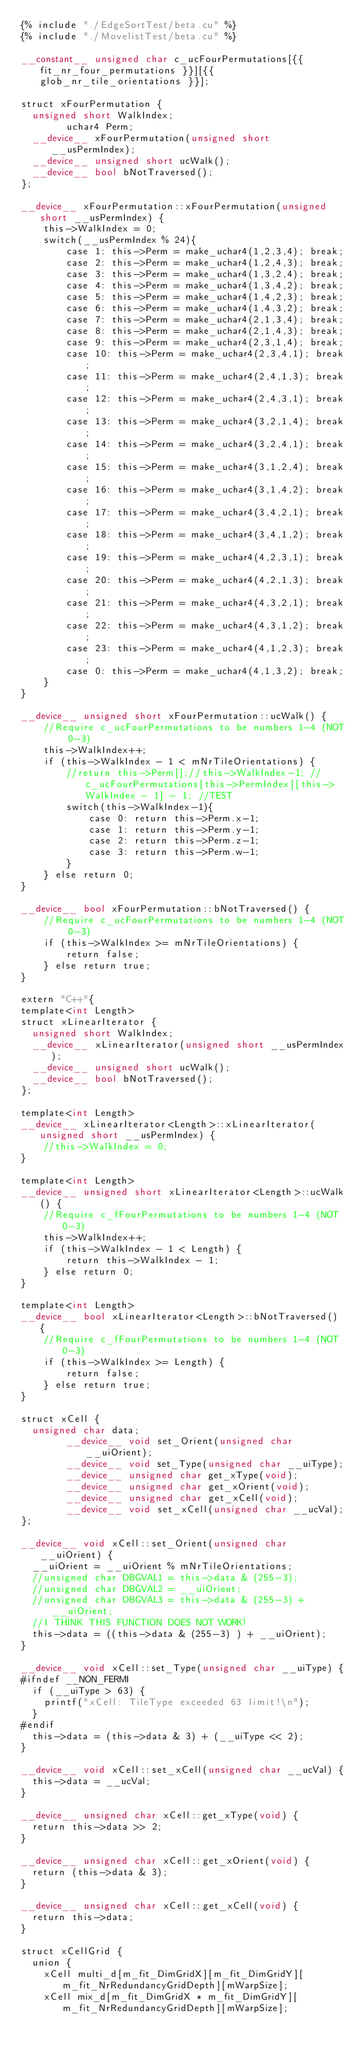Convert code to text. <code><loc_0><loc_0><loc_500><loc_500><_Cuda_>{% include "./EdgeSortTest/beta.cu" %}
{% include "./MovelistTest/beta.cu" %}

__constant__ unsigned char c_ucFourPermutations[{{ fit_nr_four_permutations }}][{{ glob_nr_tile_orientations }}];

struct xFourPermutation {
	unsigned short WalkIndex;
        uchar4 Perm;
	__device__ xFourPermutation(unsigned short __usPermIndex);
	__device__ unsigned short ucWalk();
	__device__ bool bNotTraversed();
};

__device__ xFourPermutation::xFourPermutation(unsigned short __usPermIndex) {
    this->WalkIndex = 0;
    switch(__usPermIndex % 24){
        case 1: this->Perm = make_uchar4(1,2,3,4); break;
        case 2: this->Perm = make_uchar4(1,2,4,3); break;
        case 3: this->Perm = make_uchar4(1,3,2,4); break;
        case 4: this->Perm = make_uchar4(1,3,4,2); break;
        case 5: this->Perm = make_uchar4(1,4,2,3); break;
        case 6: this->Perm = make_uchar4(1,4,3,2); break;
        case 7: this->Perm = make_uchar4(2,1,3,4); break;
        case 8: this->Perm = make_uchar4(2,1,4,3); break;
        case 9: this->Perm = make_uchar4(2,3,1,4); break;
        case 10: this->Perm = make_uchar4(2,3,4,1); break;
        case 11: this->Perm = make_uchar4(2,4,1,3); break;
        case 12: this->Perm = make_uchar4(2,4,3,1); break;
        case 13: this->Perm = make_uchar4(3,2,1,4); break;
        case 14: this->Perm = make_uchar4(3,2,4,1); break;
        case 15: this->Perm = make_uchar4(3,1,2,4); break;
        case 16: this->Perm = make_uchar4(3,1,4,2); break;
        case 17: this->Perm = make_uchar4(3,4,2,1); break;
        case 18: this->Perm = make_uchar4(3,4,1,2); break;
        case 19: this->Perm = make_uchar4(4,2,3,1); break;
        case 20: this->Perm = make_uchar4(4,2,1,3); break;
        case 21: this->Perm = make_uchar4(4,3,2,1); break;
        case 22: this->Perm = make_uchar4(4,3,1,2); break;
        case 23: this->Perm = make_uchar4(4,1,2,3); break;
        case 0: this->Perm = make_uchar4(4,1,3,2); break;
    }
}

__device__ unsigned short xFourPermutation::ucWalk() {
    //Require c_ucFourPermutations to be numbers 1-4 (NOT 0-3)
    this->WalkIndex++;
    if (this->WalkIndex - 1 < mNrTileOrientations) {
        //return this->Perm[];//this->WalkIndex-1; //c_ucFourPermutations[this->PermIndex][this->WalkIndex - 1] - 1; //TEST
        switch(this->WalkIndex-1){
            case 0: return this->Perm.x-1;
            case 1: return this->Perm.y-1;
            case 2: return this->Perm.z-1;
            case 3: return this->Perm.w-1;            
        }
    } else return 0;
}

__device__ bool xFourPermutation::bNotTraversed() {
    //Require c_ucFourPermutations to be numbers 1-4 (NOT 0-3)
    if (this->WalkIndex >= mNrTileOrientations) {
        return false;
    } else return true;
}

extern "C++"{
template<int Length>
struct xLinearIterator {
	unsigned short WalkIndex;
	__device__ xLinearIterator(unsigned short __usPermIndex);
	__device__ unsigned short ucWalk();
	__device__ bool bNotTraversed();
};

template<int Length>
__device__ xLinearIterator<Length>::xLinearIterator(unsigned short __usPermIndex) {
    //this->WalkIndex = 0;
}

template<int Length>
__device__ unsigned short xLinearIterator<Length>::ucWalk() {
    //Require c_fFourPermutations to be numbers 1-4 (NOT 0-3)
    this->WalkIndex++;
    if (this->WalkIndex - 1 < Length) {
        return this->WalkIndex - 1;
    } else return 0;
}

template<int Length>        
__device__ bool xLinearIterator<Length>::bNotTraversed() {
    //Require c_fFourPermutations to be numbers 1-4 (NOT 0-3)
    if (this->WalkIndex >= Length) {
        return false;
    } else return true;
}

struct xCell {
	unsigned char data;
        __device__ void set_Orient(unsigned char __uiOrient);
        __device__ void set_Type(unsigned char __uiType);
        __device__ unsigned char get_xType(void);
        __device__ unsigned char get_xOrient(void);
        __device__ unsigned char get_xCell(void);
        __device__ void set_xCell(unsigned char __ucVal);
};

__device__ void xCell::set_Orient(unsigned char __uiOrient) {
	__uiOrient = __uiOrient % mNrTileOrientations;
	//unsigned char DBGVAL1 = this->data & (255-3);
	//unsigned char DBGVAL2 = __uiOrient;
	//unsigned char DBGVAL3 = this->data & (255-3) + __uiOrient;
	//I THINK THIS FUNCTION DOES NOT WORK!
	this->data = ((this->data & (255-3) ) + __uiOrient);
}

__device__ void xCell::set_Type(unsigned char __uiType) {
#ifndef __NON_FERMI
	if (__uiType > 63) {
		printf("xCell: TileType exceeded 63 limit!\n");
	}
#endif
	this->data = (this->data & 3) + (__uiType << 2);
}

__device__ void xCell::set_xCell(unsigned char __ucVal) {
	this->data = __ucVal;
}

__device__ unsigned char xCell::get_xType(void) {
	return this->data >> 2;
}

__device__ unsigned char xCell::get_xOrient(void) {
	return (this->data & 3);
}

__device__ unsigned char xCell::get_xCell(void) {
	return this->data;
}

struct xCellGrid {
	union {
		xCell multi_d[m_fit_DimGridX][m_fit_DimGridY][m_fit_NrRedundancyGridDepth][mWarpSize];
		xCell mix_d[m_fit_DimGridX * m_fit_DimGridY][m_fit_NrRedundancyGridDepth][mWarpSize];</code> 